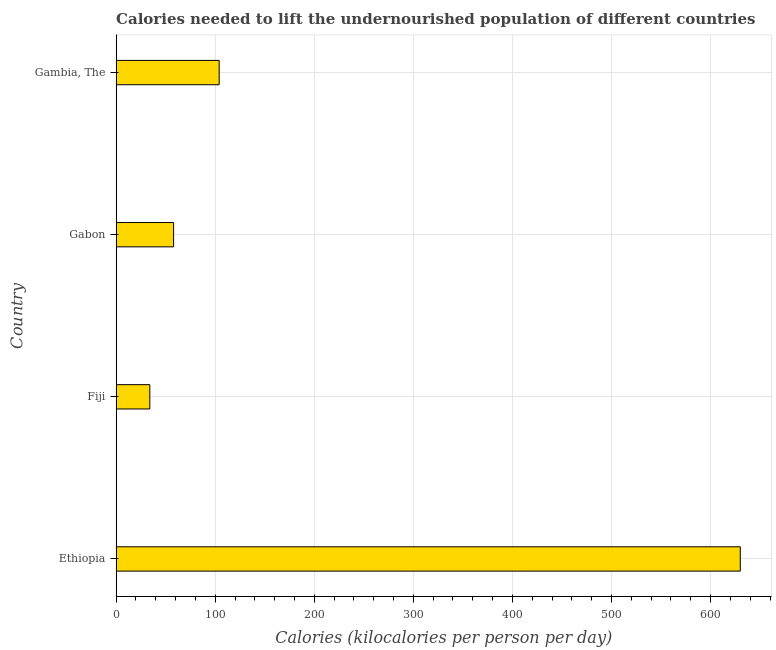Does the graph contain any zero values?
Your answer should be very brief. No. Does the graph contain grids?
Ensure brevity in your answer.  Yes. What is the title of the graph?
Give a very brief answer. Calories needed to lift the undernourished population of different countries. What is the label or title of the X-axis?
Ensure brevity in your answer.  Calories (kilocalories per person per day). What is the label or title of the Y-axis?
Offer a very short reply. Country. What is the depth of food deficit in Gabon?
Give a very brief answer. 58. Across all countries, what is the maximum depth of food deficit?
Provide a succinct answer. 630. Across all countries, what is the minimum depth of food deficit?
Provide a short and direct response. 34. In which country was the depth of food deficit maximum?
Your response must be concise. Ethiopia. In which country was the depth of food deficit minimum?
Provide a succinct answer. Fiji. What is the sum of the depth of food deficit?
Provide a short and direct response. 826. What is the difference between the depth of food deficit in Ethiopia and Gambia, The?
Ensure brevity in your answer.  526. What is the average depth of food deficit per country?
Keep it short and to the point. 206.5. What is the median depth of food deficit?
Your answer should be compact. 81. What is the ratio of the depth of food deficit in Gabon to that in Gambia, The?
Give a very brief answer. 0.56. Is the depth of food deficit in Fiji less than that in Gabon?
Offer a very short reply. Yes. What is the difference between the highest and the second highest depth of food deficit?
Provide a short and direct response. 526. Is the sum of the depth of food deficit in Gabon and Gambia, The greater than the maximum depth of food deficit across all countries?
Your answer should be very brief. No. What is the difference between the highest and the lowest depth of food deficit?
Your answer should be very brief. 596. In how many countries, is the depth of food deficit greater than the average depth of food deficit taken over all countries?
Offer a very short reply. 1. How many bars are there?
Ensure brevity in your answer.  4. Are the values on the major ticks of X-axis written in scientific E-notation?
Offer a terse response. No. What is the Calories (kilocalories per person per day) in Ethiopia?
Provide a short and direct response. 630. What is the Calories (kilocalories per person per day) in Gambia, The?
Make the answer very short. 104. What is the difference between the Calories (kilocalories per person per day) in Ethiopia and Fiji?
Keep it short and to the point. 596. What is the difference between the Calories (kilocalories per person per day) in Ethiopia and Gabon?
Provide a short and direct response. 572. What is the difference between the Calories (kilocalories per person per day) in Ethiopia and Gambia, The?
Offer a very short reply. 526. What is the difference between the Calories (kilocalories per person per day) in Fiji and Gabon?
Make the answer very short. -24. What is the difference between the Calories (kilocalories per person per day) in Fiji and Gambia, The?
Offer a very short reply. -70. What is the difference between the Calories (kilocalories per person per day) in Gabon and Gambia, The?
Keep it short and to the point. -46. What is the ratio of the Calories (kilocalories per person per day) in Ethiopia to that in Fiji?
Your response must be concise. 18.53. What is the ratio of the Calories (kilocalories per person per day) in Ethiopia to that in Gabon?
Offer a very short reply. 10.86. What is the ratio of the Calories (kilocalories per person per day) in Ethiopia to that in Gambia, The?
Keep it short and to the point. 6.06. What is the ratio of the Calories (kilocalories per person per day) in Fiji to that in Gabon?
Your response must be concise. 0.59. What is the ratio of the Calories (kilocalories per person per day) in Fiji to that in Gambia, The?
Your answer should be compact. 0.33. What is the ratio of the Calories (kilocalories per person per day) in Gabon to that in Gambia, The?
Your response must be concise. 0.56. 